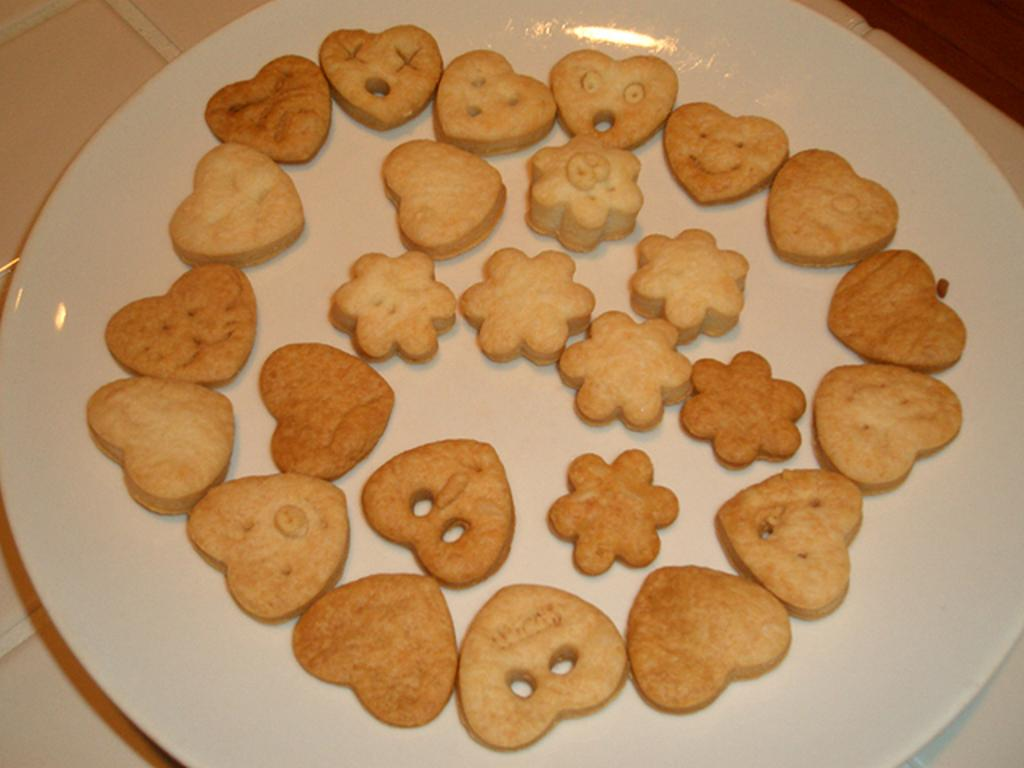What is present on the plate in the image? The plate is full of food items. Where is the plate located in the image? The plate is placed on a white surface. Can you describe the type of food items on the plate? Unfortunately, the specific food items cannot be determined from the provided facts. How many tickets are visible on the plate in the image? There are no tickets present on the plate in the image. What type of snakes can be seen slithering around the food items on the plate? There are no snakes present on the plate in the image. 